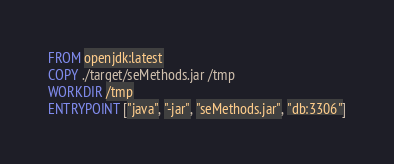<code> <loc_0><loc_0><loc_500><loc_500><_Dockerfile_>FROM openjdk:latest
COPY ./target/seMethods.jar /tmp
WORKDIR /tmp
ENTRYPOINT ["java", "-jar", "seMethods.jar", "db:3306"]
</code> 